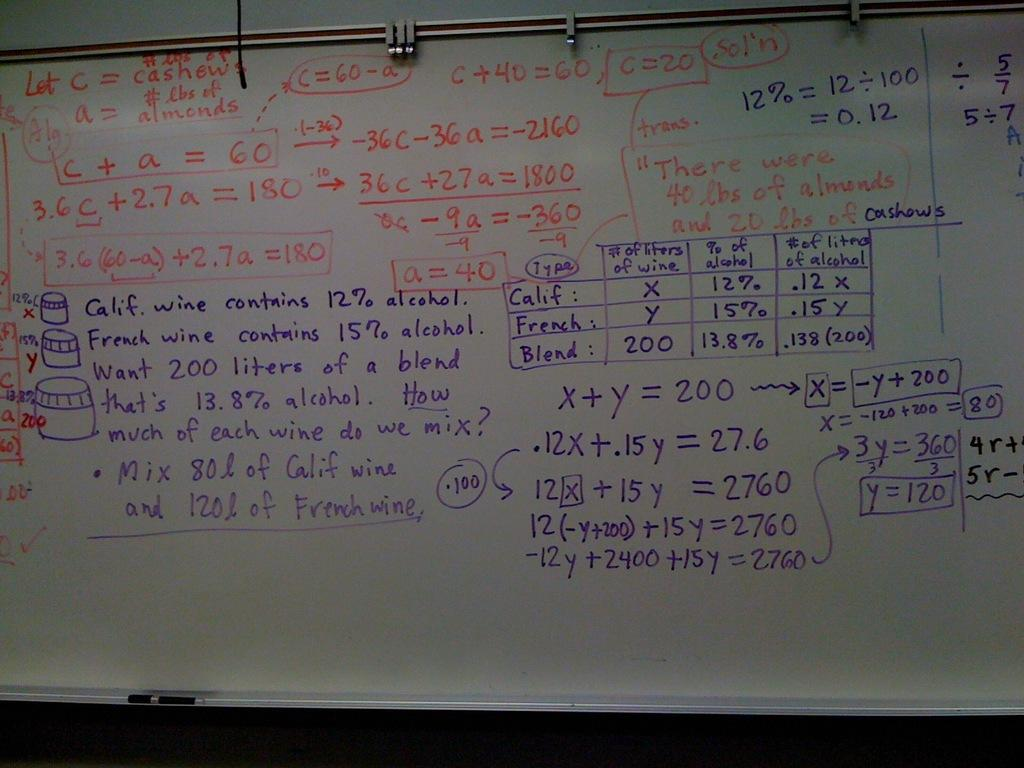<image>
Describe the image concisely. A whiteboard with writing on it related to wine mixing. 